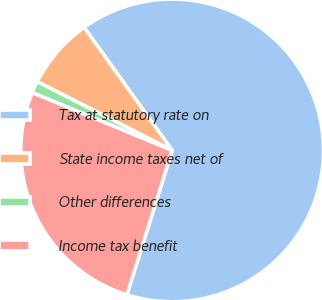<chart> <loc_0><loc_0><loc_500><loc_500><pie_chart><fcel>Tax at statutory rate on<fcel>State income taxes net of<fcel>Other differences<fcel>Income tax benefit<nl><fcel>64.72%<fcel>7.61%<fcel>1.27%<fcel>26.41%<nl></chart> 